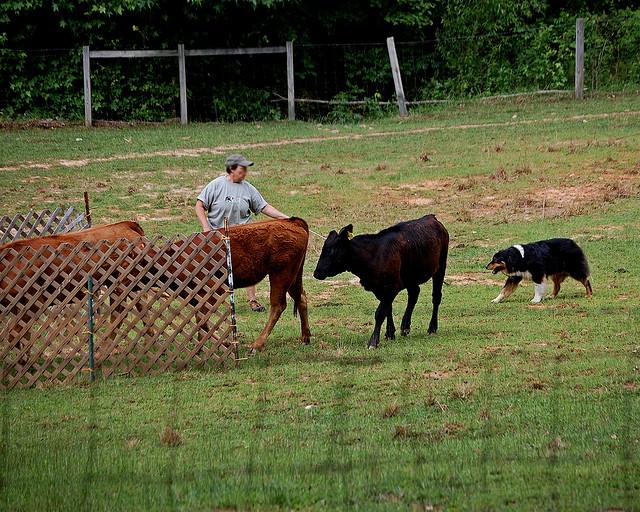Is the gate open?
Quick response, please. Yes. What is in the foreground of the image?
Give a very brief answer. Fence. Are all the animals the same type of animal?
Give a very brief answer. No. What breed of dog is in this photograph?
Write a very short answer. Collie. What is the likely purpose of the pole?
Concise answer only. Fence. 